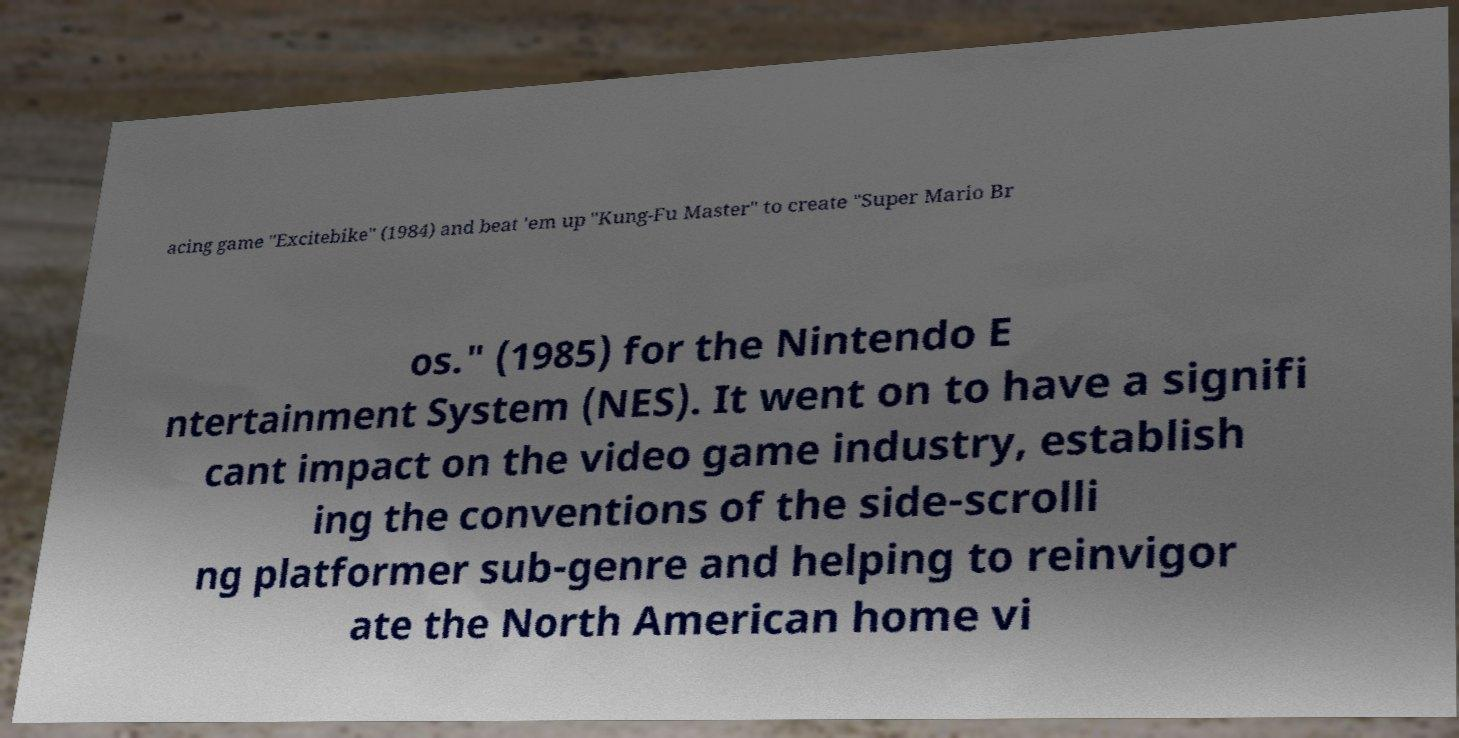What messages or text are displayed in this image? I need them in a readable, typed format. acing game "Excitebike" (1984) and beat 'em up "Kung-Fu Master" to create "Super Mario Br os." (1985) for the Nintendo E ntertainment System (NES). It went on to have a signifi cant impact on the video game industry, establish ing the conventions of the side-scrolli ng platformer sub-genre and helping to reinvigor ate the North American home vi 